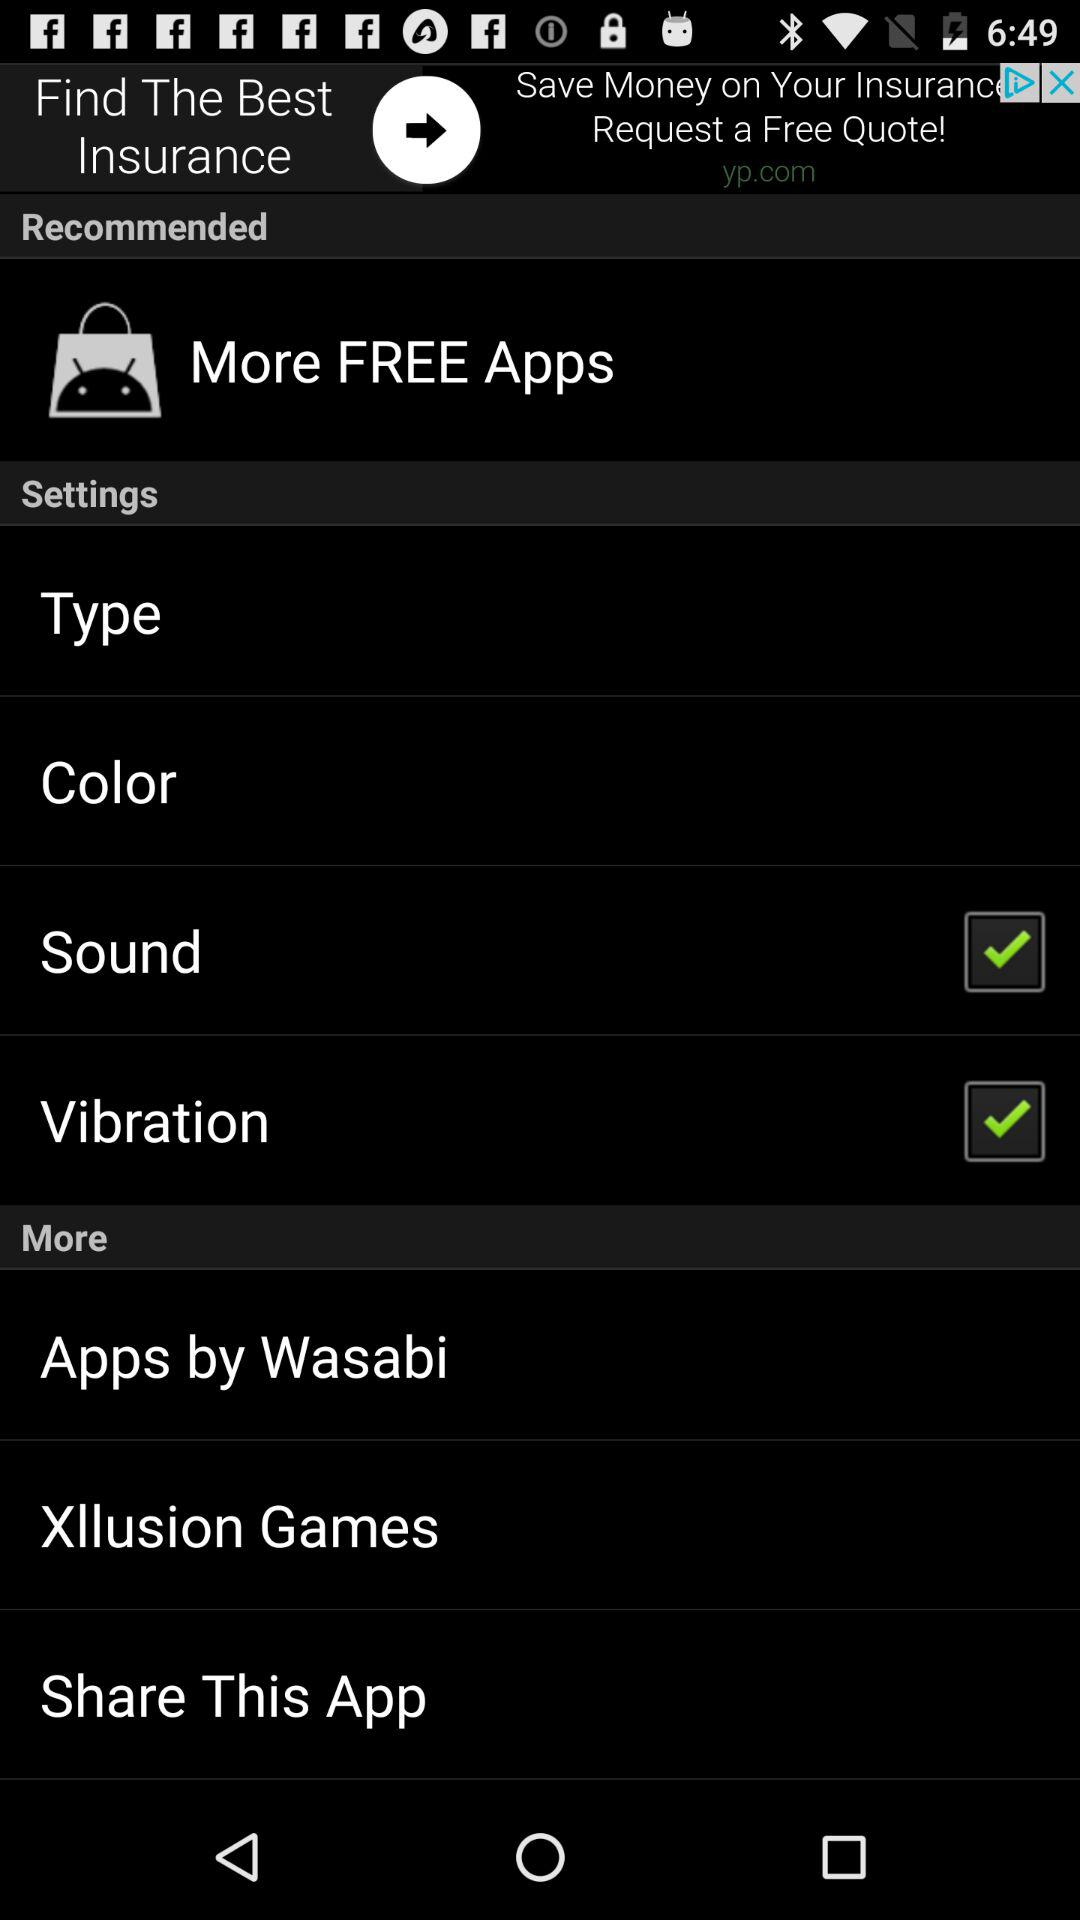What is the status of "Vibration"? The status is "on". 